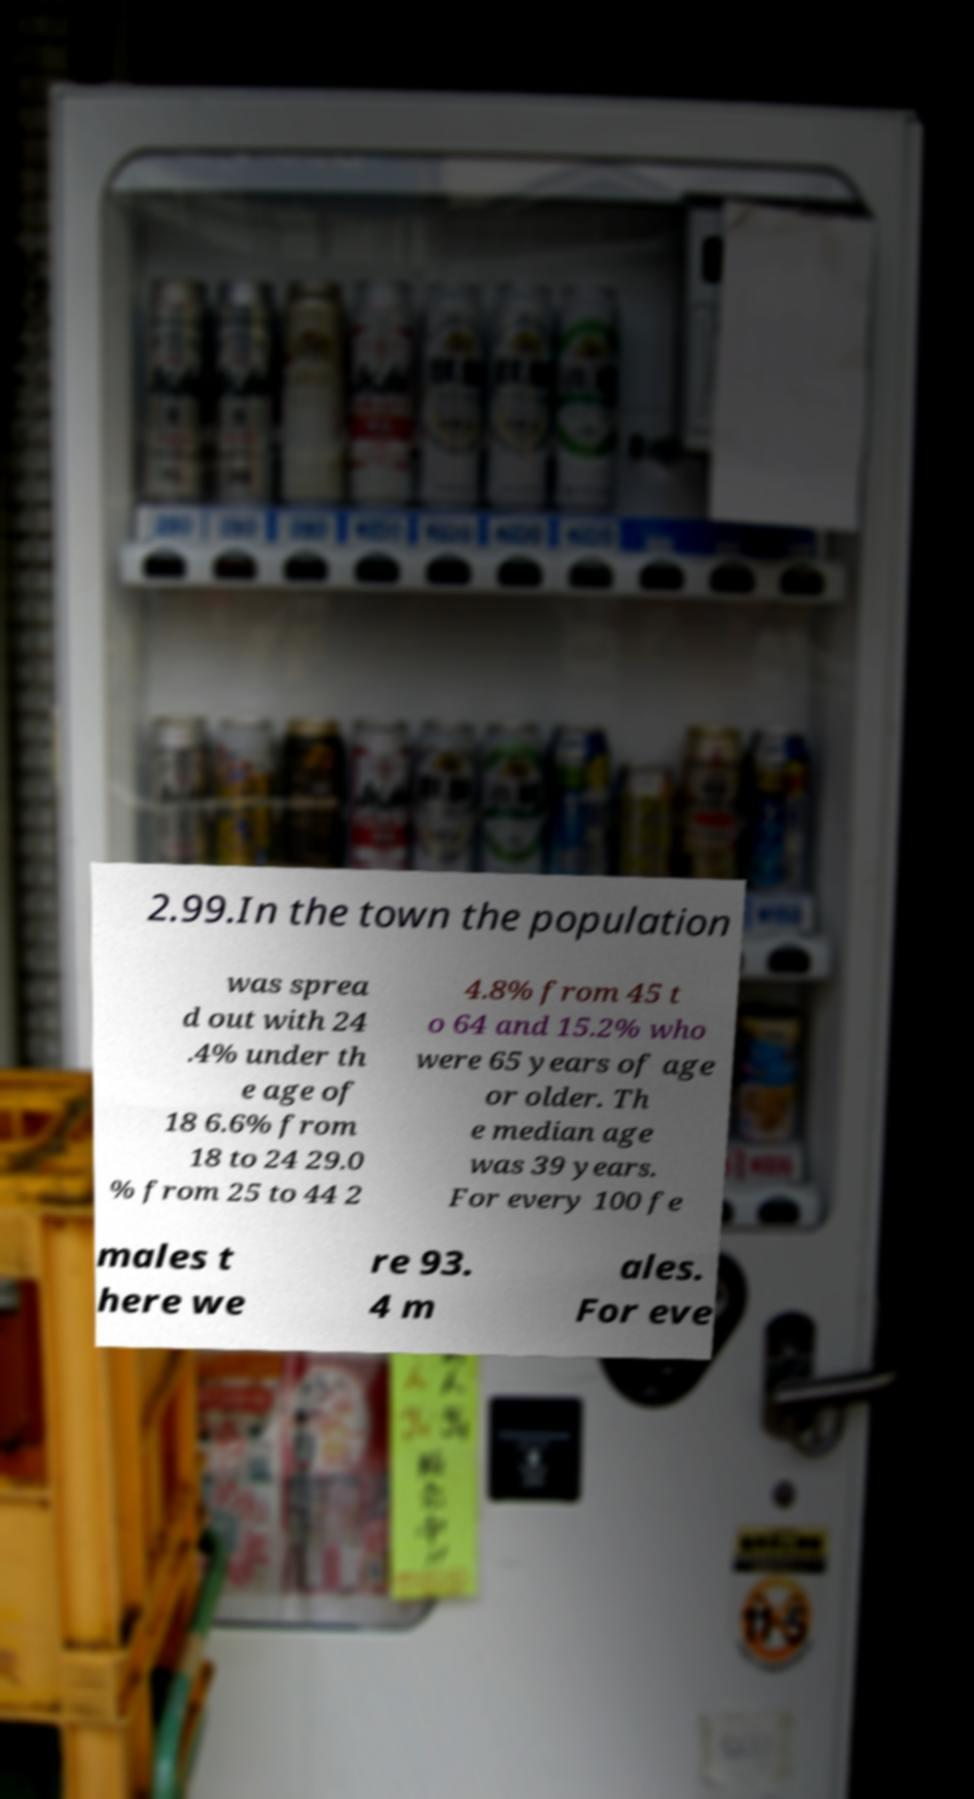Could you extract and type out the text from this image? 2.99.In the town the population was sprea d out with 24 .4% under th e age of 18 6.6% from 18 to 24 29.0 % from 25 to 44 2 4.8% from 45 t o 64 and 15.2% who were 65 years of age or older. Th e median age was 39 years. For every 100 fe males t here we re 93. 4 m ales. For eve 